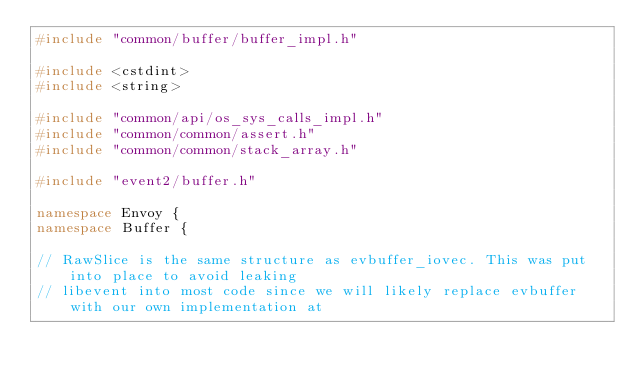Convert code to text. <code><loc_0><loc_0><loc_500><loc_500><_C++_>#include "common/buffer/buffer_impl.h"

#include <cstdint>
#include <string>

#include "common/api/os_sys_calls_impl.h"
#include "common/common/assert.h"
#include "common/common/stack_array.h"

#include "event2/buffer.h"

namespace Envoy {
namespace Buffer {

// RawSlice is the same structure as evbuffer_iovec. This was put into place to avoid leaking
// libevent into most code since we will likely replace evbuffer with our own implementation at</code> 